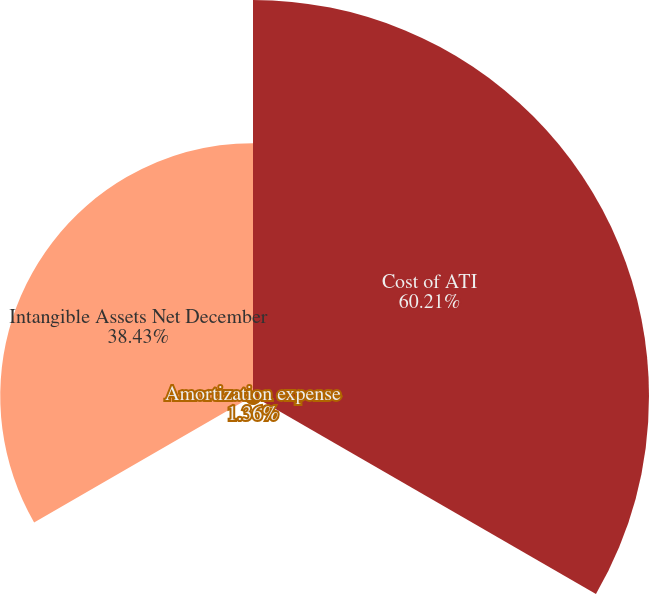Convert chart to OTSL. <chart><loc_0><loc_0><loc_500><loc_500><pie_chart><fcel>Cost of ATI<fcel>Amortization expense<fcel>Intangible Assets Net December<nl><fcel>60.21%<fcel>1.36%<fcel>38.43%<nl></chart> 